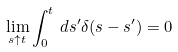Convert formula to latex. <formula><loc_0><loc_0><loc_500><loc_500>\lim _ { s \uparrow t } \int _ { 0 } ^ { t } \, d s ^ { \prime } \delta ( s - s ^ { \prime } ) = 0</formula> 